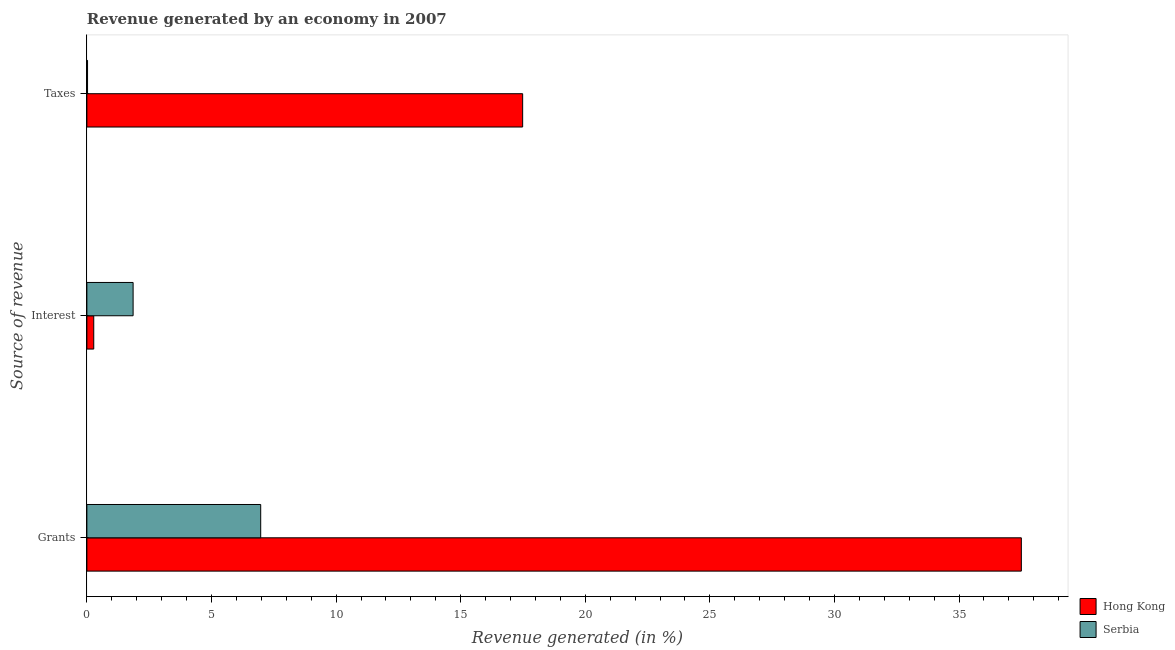Are the number of bars per tick equal to the number of legend labels?
Provide a short and direct response. Yes. How many bars are there on the 2nd tick from the top?
Offer a terse response. 2. What is the label of the 3rd group of bars from the top?
Your answer should be compact. Grants. What is the percentage of revenue generated by interest in Serbia?
Ensure brevity in your answer.  1.86. Across all countries, what is the maximum percentage of revenue generated by taxes?
Ensure brevity in your answer.  17.49. Across all countries, what is the minimum percentage of revenue generated by interest?
Your answer should be very brief. 0.28. In which country was the percentage of revenue generated by taxes maximum?
Provide a succinct answer. Hong Kong. In which country was the percentage of revenue generated by taxes minimum?
Keep it short and to the point. Serbia. What is the total percentage of revenue generated by grants in the graph?
Give a very brief answer. 44.47. What is the difference between the percentage of revenue generated by grants in Serbia and that in Hong Kong?
Your answer should be compact. -30.52. What is the difference between the percentage of revenue generated by grants in Hong Kong and the percentage of revenue generated by taxes in Serbia?
Your answer should be very brief. 37.47. What is the average percentage of revenue generated by grants per country?
Provide a short and direct response. 22.24. What is the difference between the percentage of revenue generated by taxes and percentage of revenue generated by grants in Serbia?
Make the answer very short. -6.95. What is the ratio of the percentage of revenue generated by grants in Serbia to that in Hong Kong?
Give a very brief answer. 0.19. Is the percentage of revenue generated by grants in Serbia less than that in Hong Kong?
Your response must be concise. Yes. What is the difference between the highest and the second highest percentage of revenue generated by taxes?
Provide a succinct answer. 17.46. What is the difference between the highest and the lowest percentage of revenue generated by taxes?
Offer a terse response. 17.46. In how many countries, is the percentage of revenue generated by taxes greater than the average percentage of revenue generated by taxes taken over all countries?
Your answer should be compact. 1. What does the 1st bar from the top in Grants represents?
Make the answer very short. Serbia. What does the 2nd bar from the bottom in Grants represents?
Ensure brevity in your answer.  Serbia. Is it the case that in every country, the sum of the percentage of revenue generated by grants and percentage of revenue generated by interest is greater than the percentage of revenue generated by taxes?
Provide a short and direct response. Yes. How many bars are there?
Ensure brevity in your answer.  6. Does the graph contain any zero values?
Give a very brief answer. No. Where does the legend appear in the graph?
Offer a terse response. Bottom right. How are the legend labels stacked?
Keep it short and to the point. Vertical. What is the title of the graph?
Offer a very short reply. Revenue generated by an economy in 2007. Does "Turkey" appear as one of the legend labels in the graph?
Your response must be concise. No. What is the label or title of the X-axis?
Offer a terse response. Revenue generated (in %). What is the label or title of the Y-axis?
Make the answer very short. Source of revenue. What is the Revenue generated (in %) in Hong Kong in Grants?
Give a very brief answer. 37.5. What is the Revenue generated (in %) of Serbia in Grants?
Keep it short and to the point. 6.98. What is the Revenue generated (in %) of Hong Kong in Interest?
Ensure brevity in your answer.  0.28. What is the Revenue generated (in %) of Serbia in Interest?
Make the answer very short. 1.86. What is the Revenue generated (in %) in Hong Kong in Taxes?
Keep it short and to the point. 17.49. What is the Revenue generated (in %) of Serbia in Taxes?
Provide a short and direct response. 0.03. Across all Source of revenue, what is the maximum Revenue generated (in %) of Hong Kong?
Offer a very short reply. 37.5. Across all Source of revenue, what is the maximum Revenue generated (in %) in Serbia?
Provide a succinct answer. 6.98. Across all Source of revenue, what is the minimum Revenue generated (in %) of Hong Kong?
Make the answer very short. 0.28. Across all Source of revenue, what is the minimum Revenue generated (in %) in Serbia?
Make the answer very short. 0.03. What is the total Revenue generated (in %) in Hong Kong in the graph?
Give a very brief answer. 55.26. What is the total Revenue generated (in %) in Serbia in the graph?
Your response must be concise. 8.86. What is the difference between the Revenue generated (in %) of Hong Kong in Grants and that in Interest?
Provide a short and direct response. 37.22. What is the difference between the Revenue generated (in %) of Serbia in Grants and that in Interest?
Your answer should be very brief. 5.12. What is the difference between the Revenue generated (in %) in Hong Kong in Grants and that in Taxes?
Make the answer very short. 20.01. What is the difference between the Revenue generated (in %) of Serbia in Grants and that in Taxes?
Offer a terse response. 6.95. What is the difference between the Revenue generated (in %) in Hong Kong in Interest and that in Taxes?
Ensure brevity in your answer.  -17.21. What is the difference between the Revenue generated (in %) in Serbia in Interest and that in Taxes?
Offer a terse response. 1.83. What is the difference between the Revenue generated (in %) in Hong Kong in Grants and the Revenue generated (in %) in Serbia in Interest?
Your answer should be very brief. 35.64. What is the difference between the Revenue generated (in %) in Hong Kong in Grants and the Revenue generated (in %) in Serbia in Taxes?
Provide a short and direct response. 37.47. What is the difference between the Revenue generated (in %) of Hong Kong in Interest and the Revenue generated (in %) of Serbia in Taxes?
Your answer should be compact. 0.25. What is the average Revenue generated (in %) of Hong Kong per Source of revenue?
Your response must be concise. 18.42. What is the average Revenue generated (in %) in Serbia per Source of revenue?
Your response must be concise. 2.95. What is the difference between the Revenue generated (in %) of Hong Kong and Revenue generated (in %) of Serbia in Grants?
Your answer should be compact. 30.52. What is the difference between the Revenue generated (in %) of Hong Kong and Revenue generated (in %) of Serbia in Interest?
Ensure brevity in your answer.  -1.58. What is the difference between the Revenue generated (in %) of Hong Kong and Revenue generated (in %) of Serbia in Taxes?
Your response must be concise. 17.46. What is the ratio of the Revenue generated (in %) in Hong Kong in Grants to that in Interest?
Give a very brief answer. 136.05. What is the ratio of the Revenue generated (in %) of Serbia in Grants to that in Interest?
Ensure brevity in your answer.  3.76. What is the ratio of the Revenue generated (in %) in Hong Kong in Grants to that in Taxes?
Your answer should be compact. 2.14. What is the ratio of the Revenue generated (in %) in Serbia in Grants to that in Taxes?
Your answer should be very brief. 257.79. What is the ratio of the Revenue generated (in %) of Hong Kong in Interest to that in Taxes?
Give a very brief answer. 0.02. What is the ratio of the Revenue generated (in %) in Serbia in Interest to that in Taxes?
Give a very brief answer. 68.58. What is the difference between the highest and the second highest Revenue generated (in %) of Hong Kong?
Make the answer very short. 20.01. What is the difference between the highest and the second highest Revenue generated (in %) of Serbia?
Offer a terse response. 5.12. What is the difference between the highest and the lowest Revenue generated (in %) of Hong Kong?
Give a very brief answer. 37.22. What is the difference between the highest and the lowest Revenue generated (in %) in Serbia?
Offer a terse response. 6.95. 